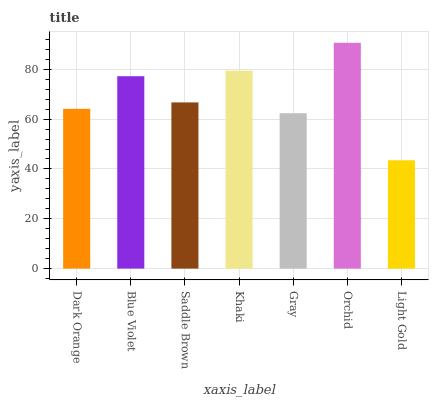Is Light Gold the minimum?
Answer yes or no. Yes. Is Orchid the maximum?
Answer yes or no. Yes. Is Blue Violet the minimum?
Answer yes or no. No. Is Blue Violet the maximum?
Answer yes or no. No. Is Blue Violet greater than Dark Orange?
Answer yes or no. Yes. Is Dark Orange less than Blue Violet?
Answer yes or no. Yes. Is Dark Orange greater than Blue Violet?
Answer yes or no. No. Is Blue Violet less than Dark Orange?
Answer yes or no. No. Is Saddle Brown the high median?
Answer yes or no. Yes. Is Saddle Brown the low median?
Answer yes or no. Yes. Is Blue Violet the high median?
Answer yes or no. No. Is Blue Violet the low median?
Answer yes or no. No. 